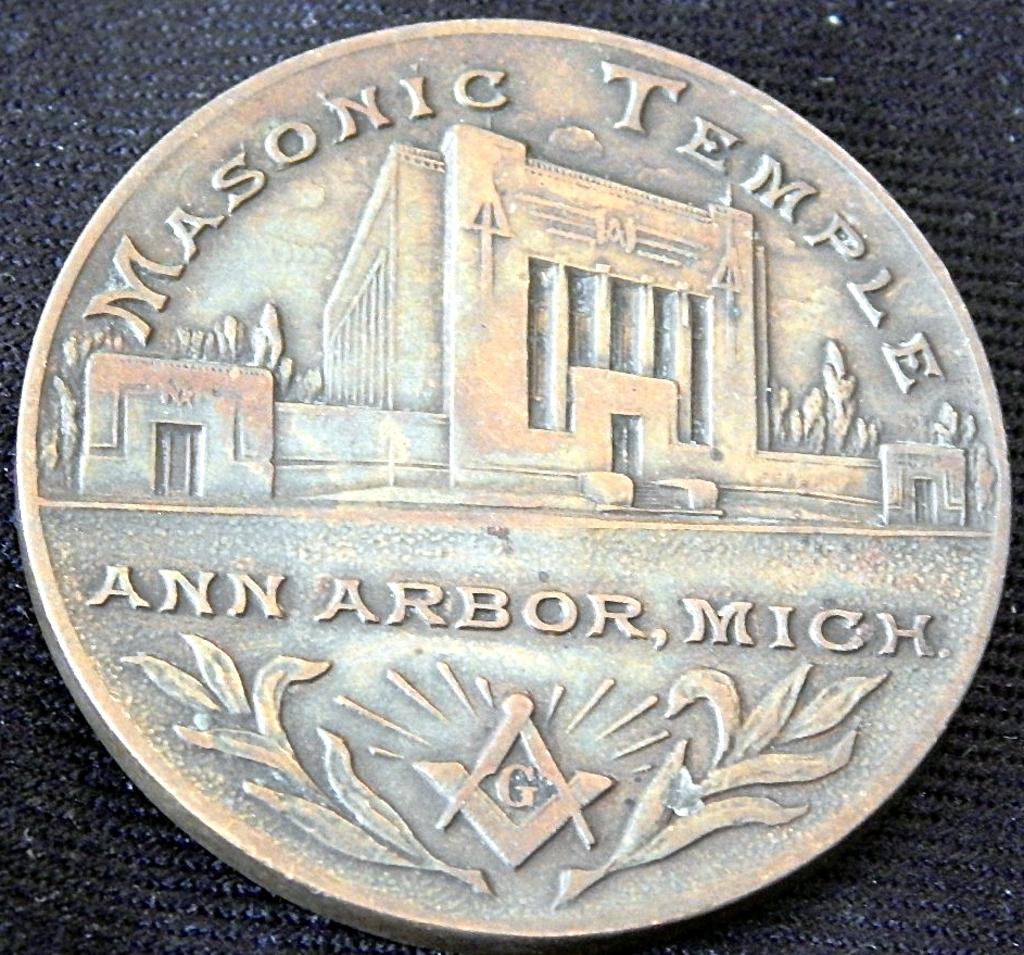<image>
Present a compact description of the photo's key features. A token displays an image of the Masonic Temple in Michigan. 